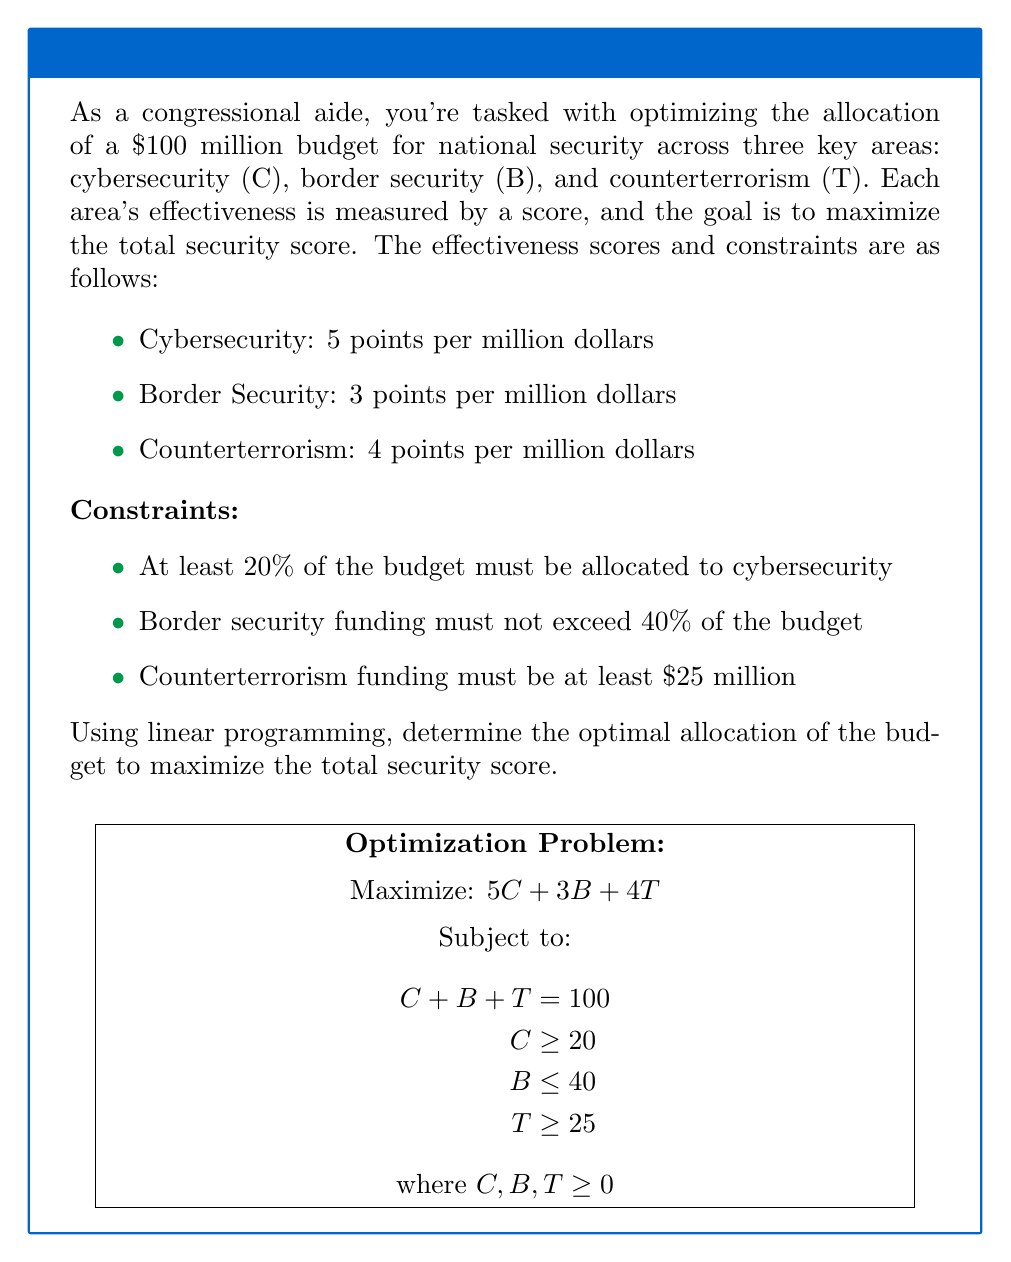Give your solution to this math problem. Let's solve this step-by-step using linear programming:

1) Define variables:
   $C$ = millions of dollars allocated to cybersecurity
   $B$ = millions of dollars allocated to border security
   $T$ = millions of dollars allocated to counterterrorism

2) Objective function:
   Maximize $Z = 5C + 3B + 4T$

3) Constraints:
   a) Total budget: $C + B + T = 100$
   b) Cybersecurity minimum (20%): $C \geq 20$
   c) Border security maximum (40%): $B \leq 40$
   d) Counterterrorism minimum: $T \geq 25$
   e) Non-negativity: $C, B, T \geq 0$

4) Set up the linear program:

   Maximize $Z = 5C + 3B + 4T$
   Subject to:
   $C + B + T = 100$
   $C \geq 20$
   $B \leq 40$
   $T \geq 25$
   $C, B, T \geq 0$

5) Solve using the simplex method or linear programming software. The optimal solution is:

   $C = 35$
   $B = 40$
   $T = 25$

6) Verify the solution:
   - Total budget: $35 + 40 + 25 = 100$ (satisfied)
   - Cybersecurity minimum: $35 > 20$ (satisfied)
   - Border security maximum: $40 \leq 40$ (satisfied)
   - Counterterrorism minimum: $25 \geq 25$ (satisfied)

7) Calculate the maximum security score:
   $Z = 5(35) + 3(40) + 4(25) = 175 + 120 + 100 = 395$

Therefore, the optimal allocation is $35 million for cybersecurity, $40 million for border security, and $25 million for counterterrorism, resulting in a maximum security score of 395 points.
Answer: Cybersecurity: $35 million, Border Security: $40 million, Counterterrorism: $25 million; Maximum score: 395 points 